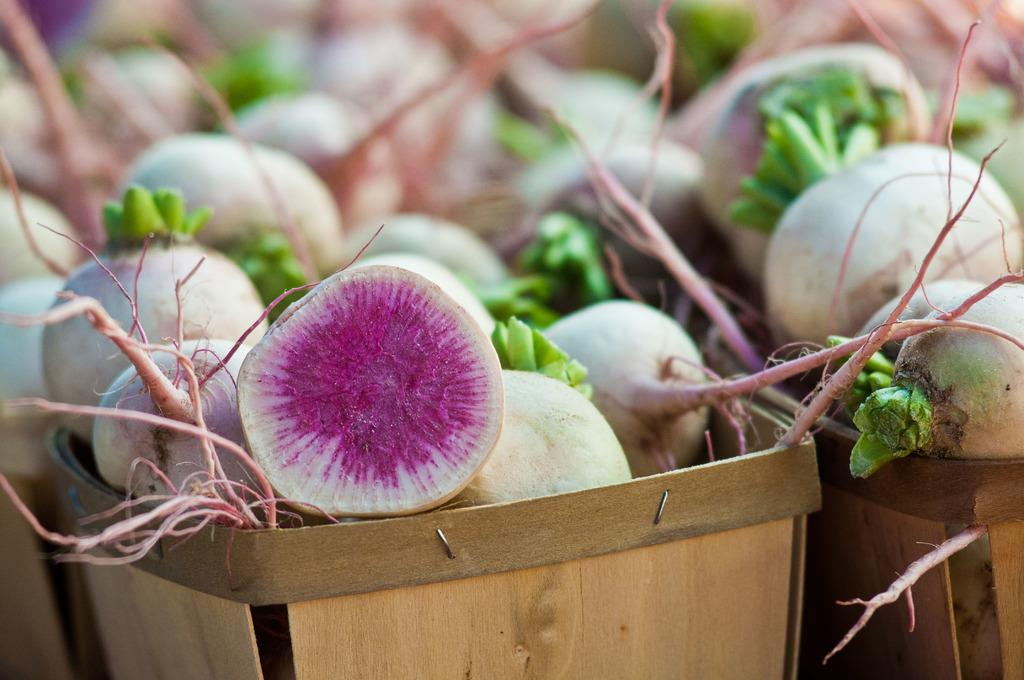What objects are present in the image? There are baskets in the image. What are the baskets holding? The baskets contain fruits or vegetables. Can you identify the type of vegetables in the baskets? The vegetables resemble beetroots. How would you describe the background of the image? The background of the image is blurred. How many times does the drain appear in the image? There is no drain present in the image. What type of fold can be seen in the image? There is no fold present in the image. 